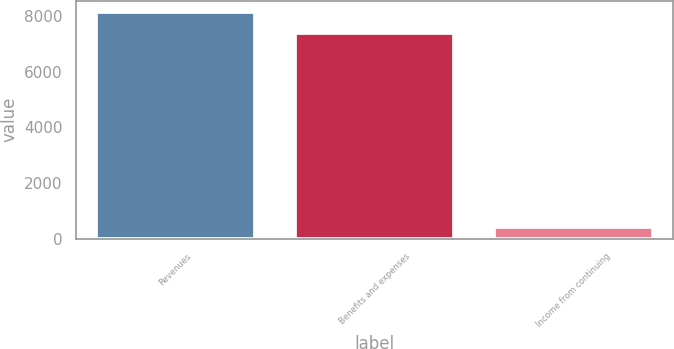Convert chart. <chart><loc_0><loc_0><loc_500><loc_500><bar_chart><fcel>Revenues<fcel>Benefits and expenses<fcel>Income from continuing<nl><fcel>8149.9<fcel>7409<fcel>403<nl></chart> 